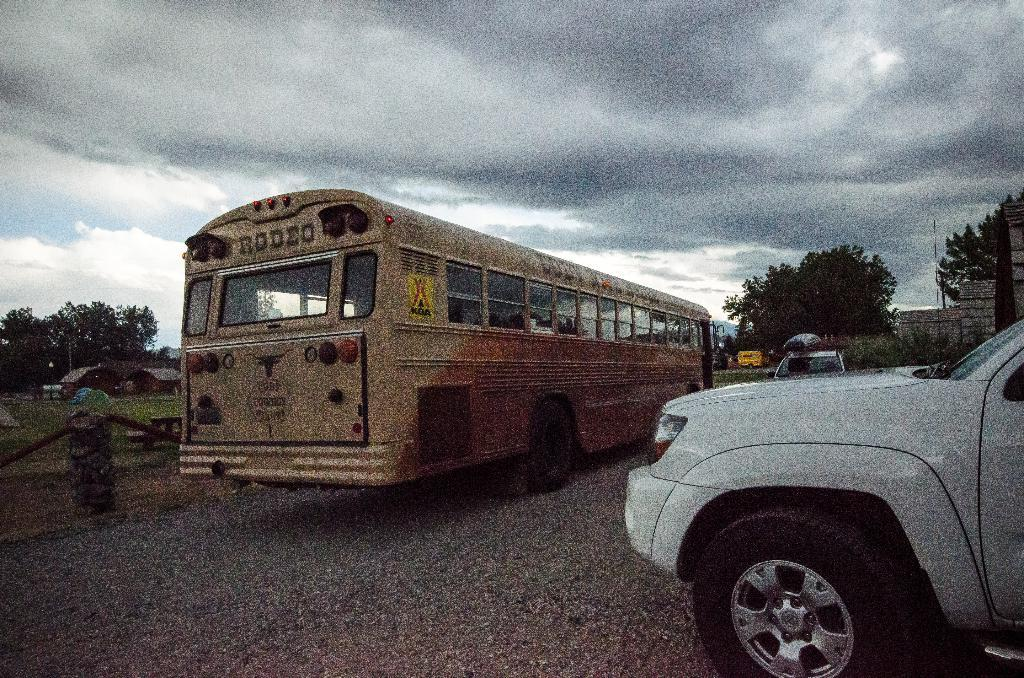Provide a one-sentence caption for the provided image. The bus is from the local rodeo in Cody. 